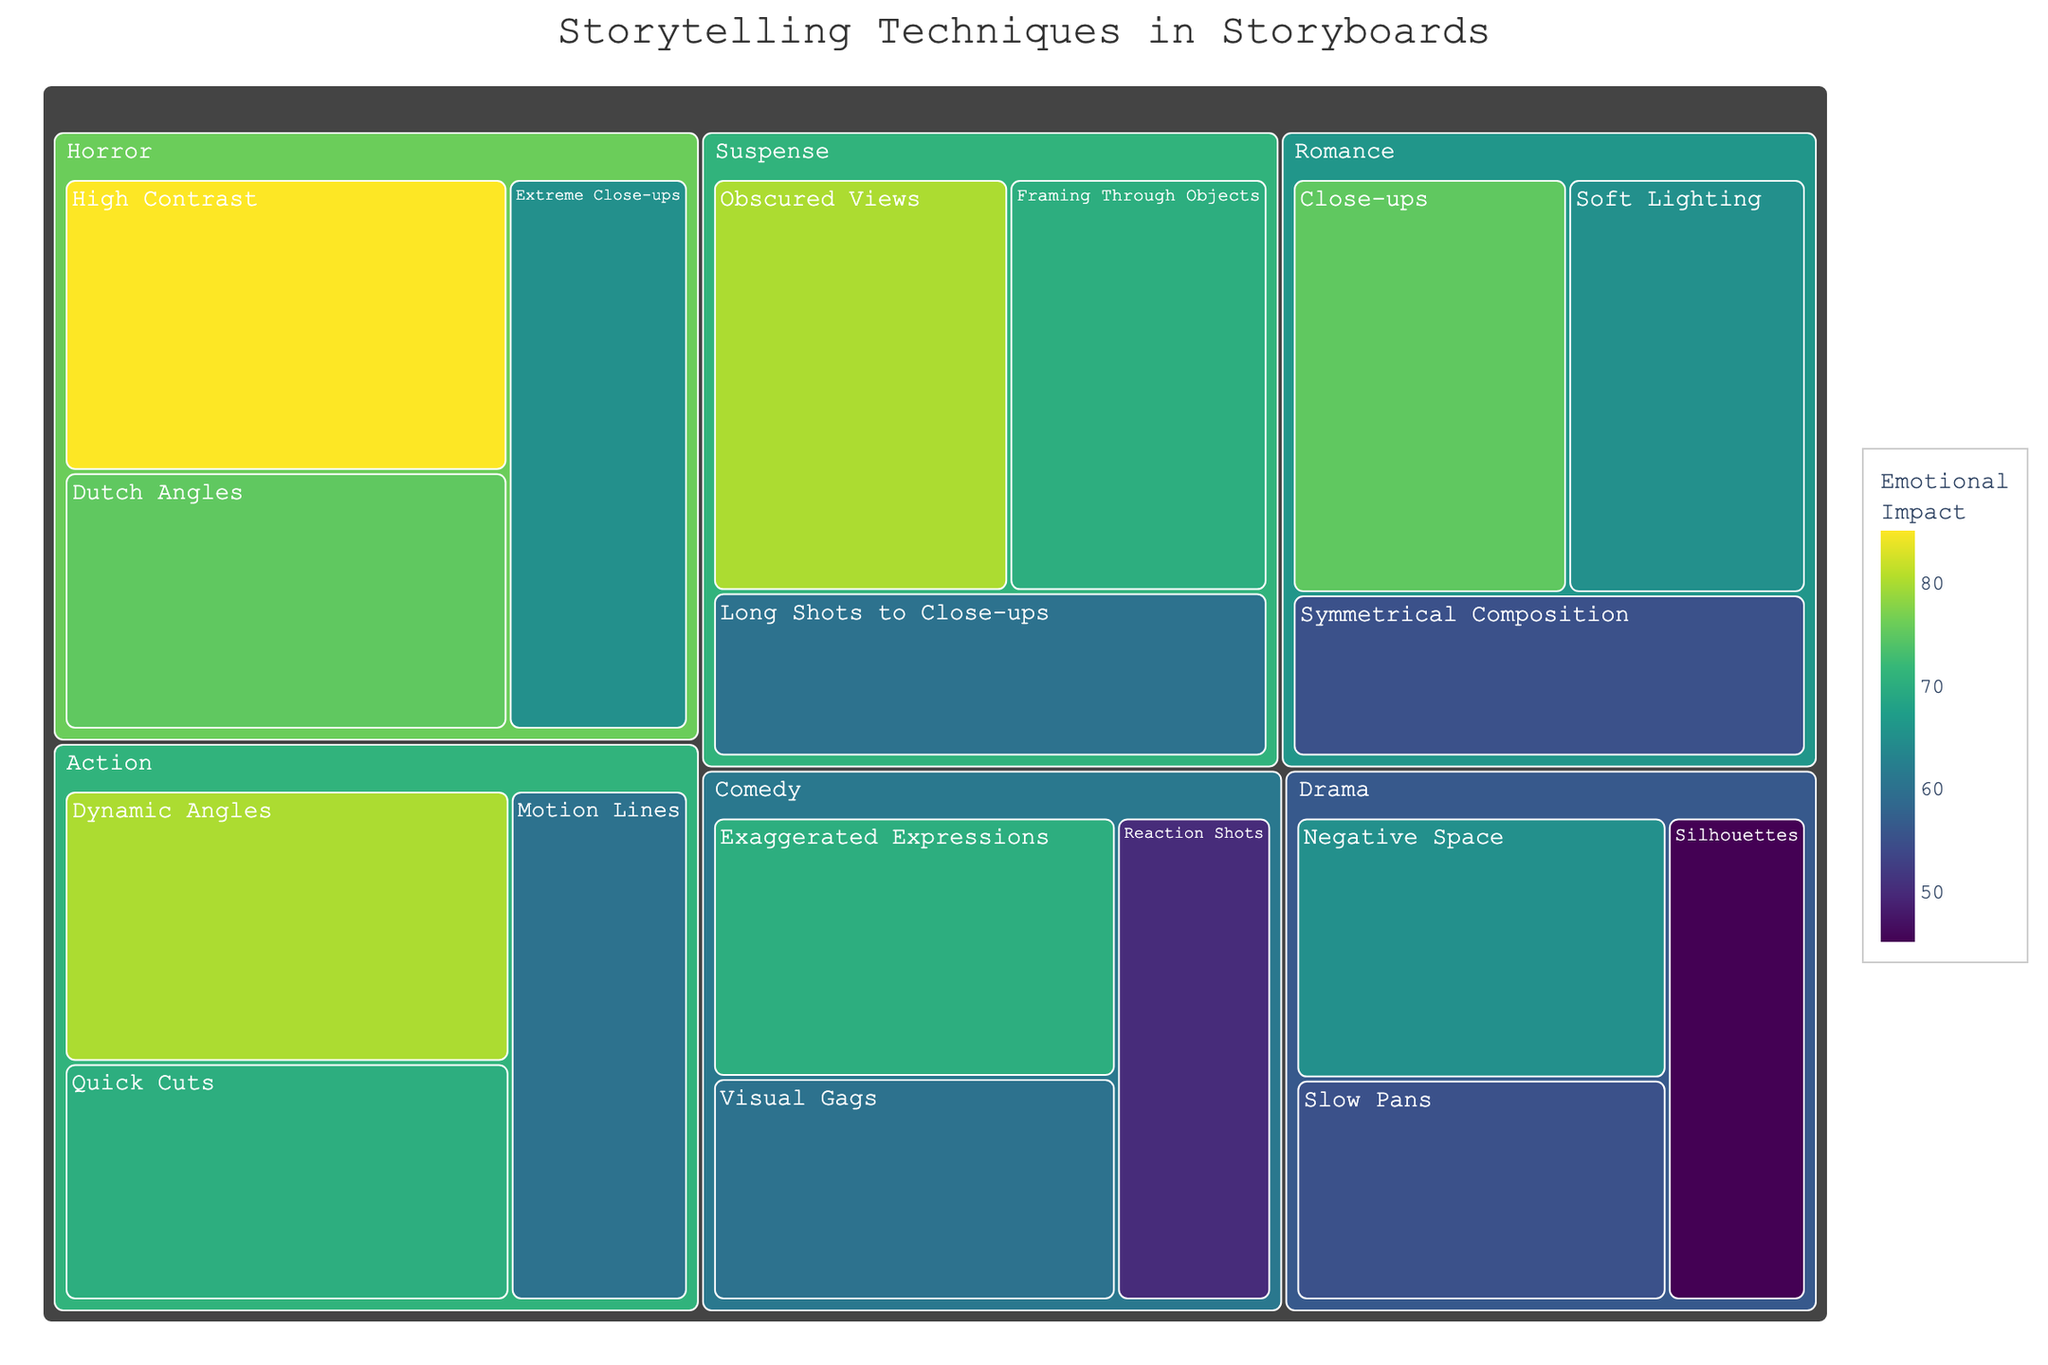What's the title of the treemap? The title is prominently displayed at the top center of the treemap.
Answer: Storytelling Techniques in Storyboards Which scene type has the highest emotional impact technique? The emotional impact value is colored from light to dark; the darkest box has the highest value. Horror with High Contrast has the highest emotional impact value of 85.
Answer: Horror What are the emotional impact values for the techniques in Romance scenes? Look at the boxes within the Romance category and note their values. The values are Close-ups (75), Soft Lighting (65), and Symmetrical Composition (55).
Answer: 75, 65, 55 Which two techniques in Suspense have the closest emotional impact values? Compare the emotional impact values under Suspense. Obscured Views (80) and Framing Through Objects (70) are closest.
Answer: Obscured Views and Framing Through Objects How does the emotional impact of Close-ups in Romance compare to Reaction Shots in Comedy? Observe the values for Close-ups under Romance (75) and Reaction Shots under Comedy (50) and compare them. Close-ups have a higher value.
Answer: Close-ups in Romance are higher What's the average emotional impact of techniques used in Action scenes? Add the emotional impact values of the techniques in Action (80, 70, 60) and divide by the number of techniques (3). (80 + 70 + 60) / 3 = 70
Answer: 70 Are there any techniques with the same emotional impact in different scene types? Scan the emotional impact values across different scene types. Extreme Close-ups in Horror and Soft Lighting in Romance both have a value of 65.
Answer: Extreme Close-ups in Horror and Soft Lighting in Romance What technique has the lowest emotional impact across all scene types? Identify the smallest value by examining all boxes. Silhouettes in Drama has the lowest impact value of 45.
Answer: Silhouettes in Drama Which scene type contains more techniques: Action or Drama? Count the number of techniques listed under Action and Drama. Action has 3 techniques; Drama also has 3 techniques. They have the same number.
Answer: Neither, they are equal What's the total emotional impact for all Comedy techniques combined? Add the emotional impact values for all techniques in Comedy. (70 + 60 + 50) = 180
Answer: 180 